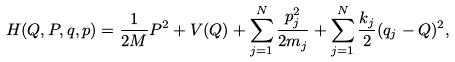Convert formula to latex. <formula><loc_0><loc_0><loc_500><loc_500>H ( Q , P , q , p ) = \frac { 1 } { 2 M } P ^ { 2 } + V ( Q ) + \sum _ { j = 1 } ^ { N } \frac { p _ { j } ^ { 2 } } { 2 m _ { j } } + \sum _ { j = 1 } ^ { N } \frac { k _ { j } } { 2 } ( q _ { j } - Q ) ^ { 2 } ,</formula> 